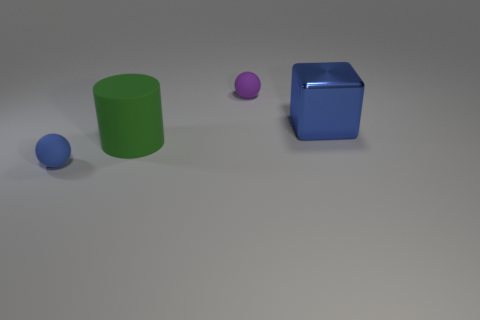The large thing that is made of the same material as the purple ball is what color?
Keep it short and to the point. Green. What material is the large blue block?
Make the answer very short. Metal. The purple rubber object has what shape?
Provide a succinct answer. Sphere. What number of metallic blocks have the same color as the metallic thing?
Offer a very short reply. 0. What is the material of the large object that is left of the purple rubber object that is behind the thing that is left of the large green object?
Ensure brevity in your answer.  Rubber. What number of yellow things are big things or matte things?
Keep it short and to the point. 0. There is a blue sphere that is in front of the ball that is behind the shiny block that is to the right of the tiny blue object; what size is it?
Keep it short and to the point. Small. What is the size of the other object that is the same shape as the small blue object?
Keep it short and to the point. Small. How many small objects are either cubes or blue metallic cylinders?
Provide a succinct answer. 0. Is the big object right of the green rubber cylinder made of the same material as the sphere that is to the right of the tiny blue matte sphere?
Make the answer very short. No. 